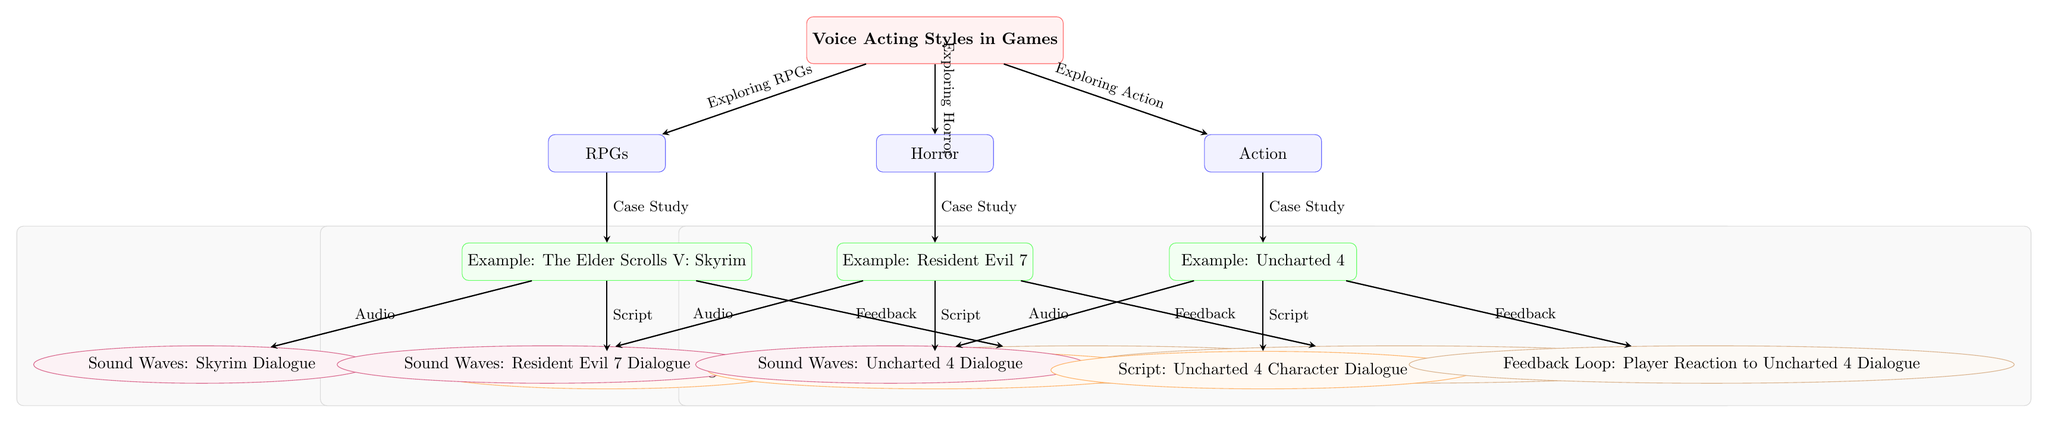What are the three main game genres discussed in the diagram? The diagram explicitly lists three genres under the main topic of voice acting styles: RPGs, Horror, and Action. These are clearly represented as nodes directly connected to the main topic.
Answer: RPGs, Horror, Action What is the example game cited for the RPG genre? The diagram shows "The Elder Scrolls V: Skyrim" as an example for the RPG genre, which is positioned directly beneath the RPG node.
Answer: The Elder Scrolls V: Skyrim How many feedback loops are indicated in the diagram? The diagram contains three feedback loops, one for each case study (Skyrim, Resident Evil 7, and Uncharted 4), as each example has a feedback node connected to it.
Answer: Three Which game is associated with the sound waves labeled 'Sound Waves: Resident Evil 7 Dialogue'? According to the diagram, the game linked with those sound waves is "Resident Evil 7," which is positioned directly above that audio node.
Answer: Resident Evil 7 What type of relationship exists between the RPG genre and its example game? The relationship depicted between the RPG genre and "The Elder Scrolls V: Skyrim" is described as a "Case Study," illustrating that Skyrim serves as a specific instance of voice acting styles within the RPG genre.
Answer: Case Study Which node connects the main topic directly to the Horror genre? The Horror genre node is directly connected to the main topic of voice acting styles through an arrow labeled "Exploring Horror," signifying the thematic link between the two nodes.
Answer: Exploring Horror What color is used to represent the genre nodes on the diagram? All genre nodes, including RPGs, Horror, and Action, are depicted in blue, which is distinctive and consistent for this category throughout the diagram.
Answer: Blue Which feedback loop is indicated for "Uncharted 4"? The diagram specifies the feedback loop for "Uncharted 4" as "Feedback Loop: Player Reaction to Uncharted 4 Dialogue," which illustrates how player reactions are taken into account in voice acting feedback.
Answer: Feedback Loop: Player Reaction to Uncharted 4 Dialogue What is the purpose of the background boxes surrounding each case study in the diagram? The background boxes serve to group the elements related to each case study (audio, script, and feedback), creating a visual distinction that helps to indicate their relationships and categorize the information about each example.
Answer: Grouping elements 